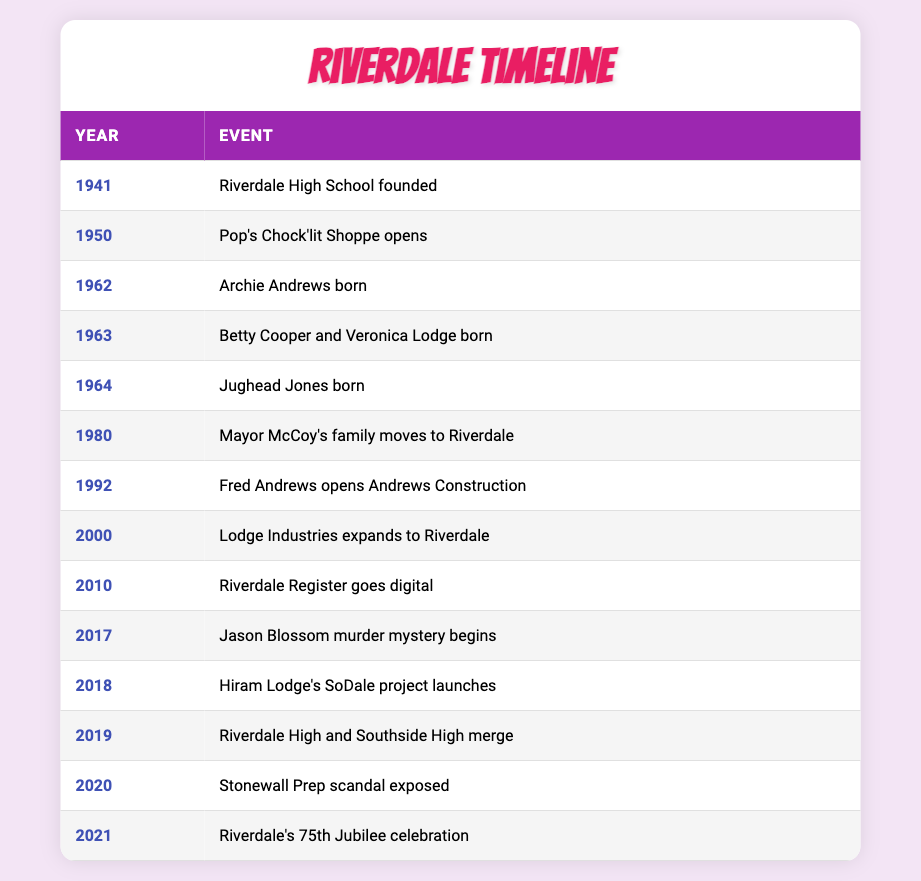What year was Riverdale High School founded? The table lists "Riverdale High School founded" under the event for the year 1941. Thus, 1941 is the specific year of this event.
Answer: 1941 What event occurred in Riverdale in 2010? By looking at the table for the year 2010, it is noted that "Riverdale Register goes digital" took place.
Answer: Riverdale Register goes digital Was Jughead Jones born before Betty Cooper and Veronica Lodge? The table shows Jughead Jones was born in 1964, while Betty Cooper and Veronica Lodge were both born in 1963. Since 1964 is after 1963, it indicates that Jughead Jones was not born before them.
Answer: No How many events are recorded before the year 2000? By counting the rows from the start through the year 1999, we see there are 8 events listed prior to the year 2000: 1941, 1950, 1962, 1963, 1964, 1980, 1992, and 2000 (which does not count), giving a total of 8 events.
Answer: 8 Which event marks the beginning of the Jason Blossom murder mystery? The table indicates that the Jason Blossom murder mystery began in the year 2017, specifically mentioning it directly as the event for that year.
Answer: Jason Blossom murder mystery begins When did Riverdale celebrate its 75th Jubilee? The table specifies that Riverdale's 75th Jubilee celebration occurred in 2021. Therefore, 2021 is the year highlighted for this event.
Answer: 2021 Is the expansion of Lodge Industries to Riverdale the latest event listed in the table? The table indicates that Lodge Industries expanded to Riverdale in 2000, while the latest event listed is Riverdale's 75th Jubilee in 2021. Hence, the expansion occurred prior to the latest event.
Answer: No What is the average interval between the founding of Riverdale High School and the opening of Pop's Chock'lit Shoppe? The founding of Riverdale High School in 1941 and the opening of Pop's Chock'lit Shoppe in 1950 gives an interval of 9 years when subtracting the founding year from the year of the shop opening (1950 - 1941 = 9). Thus, the average interval is essentially 9 years.
Answer: 9 years 